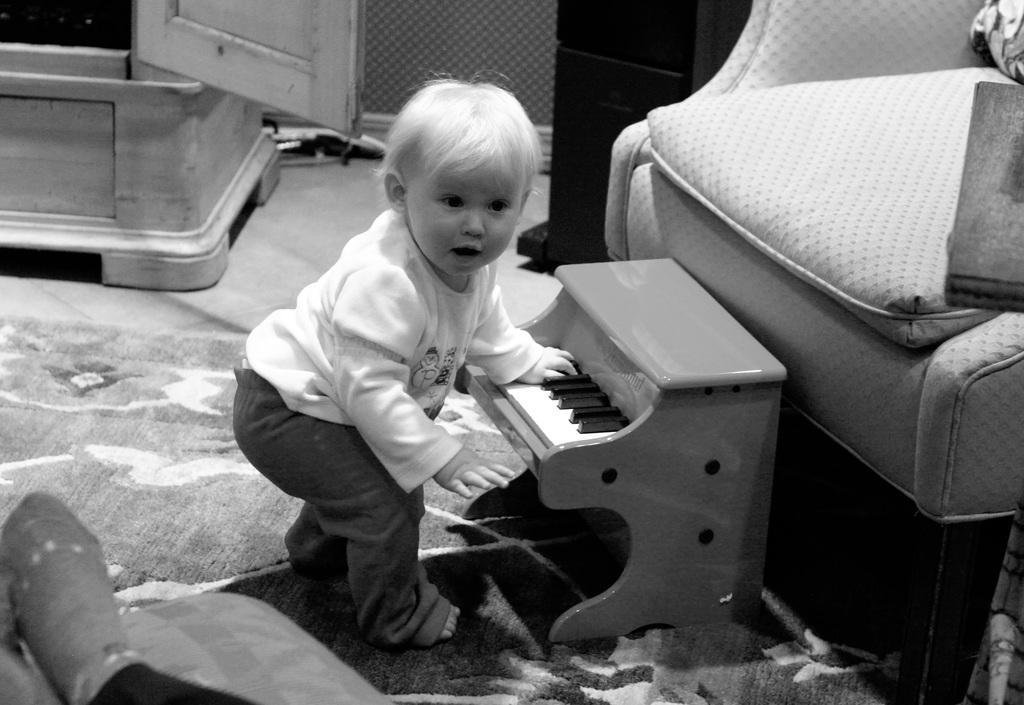Can you describe this image briefly? Baby is playing piano on the right it's a sofa. 